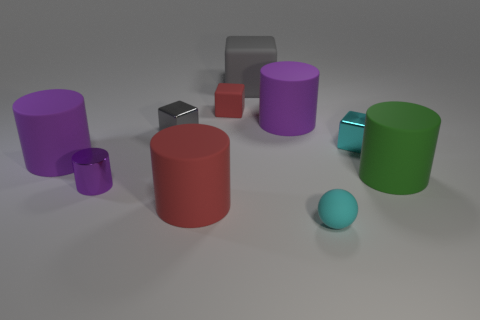Subtract all purple cylinders. How many were subtracted if there are1purple cylinders left? 2 Subtract all red blocks. How many purple cylinders are left? 3 Subtract all green cylinders. How many cylinders are left? 4 Subtract all small metal cylinders. How many cylinders are left? 4 Subtract all brown cylinders. Subtract all gray cubes. How many cylinders are left? 5 Subtract all cubes. How many objects are left? 6 Add 9 brown spheres. How many brown spheres exist? 9 Subtract 0 brown spheres. How many objects are left? 10 Subtract all small brown spheres. Subtract all big gray rubber things. How many objects are left? 9 Add 3 large green matte things. How many large green matte things are left? 4 